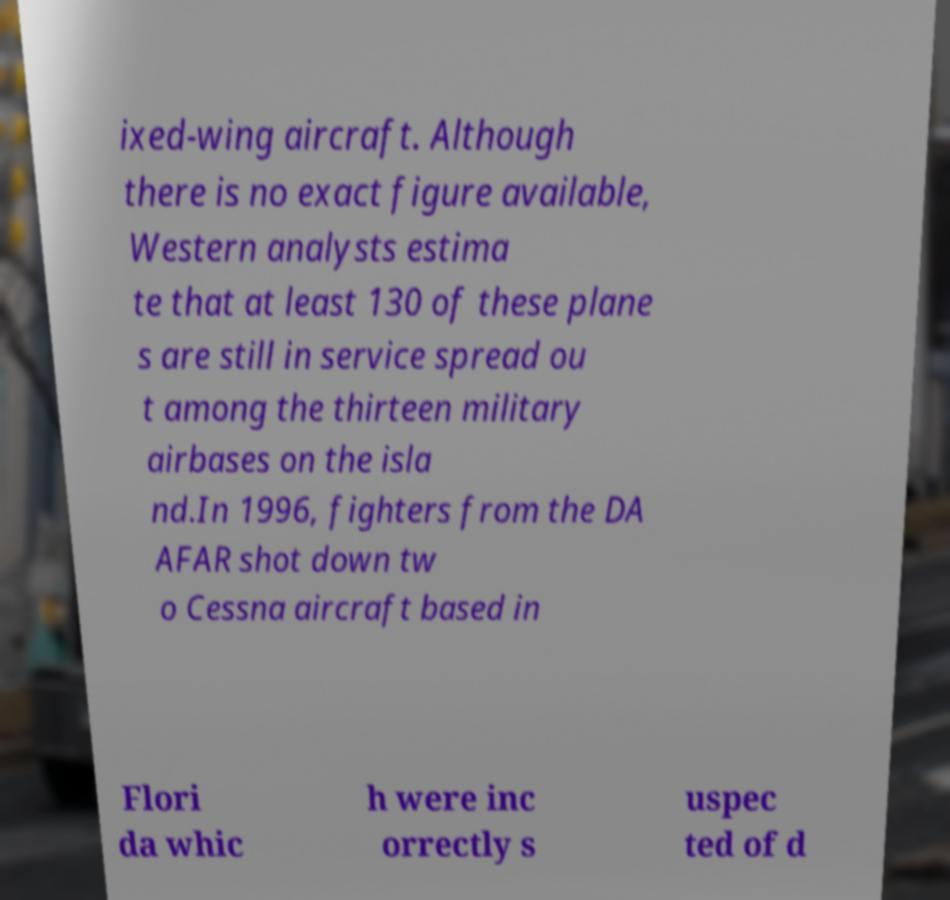There's text embedded in this image that I need extracted. Can you transcribe it verbatim? ixed-wing aircraft. Although there is no exact figure available, Western analysts estima te that at least 130 of these plane s are still in service spread ou t among the thirteen military airbases on the isla nd.In 1996, fighters from the DA AFAR shot down tw o Cessna aircraft based in Flori da whic h were inc orrectly s uspec ted of d 